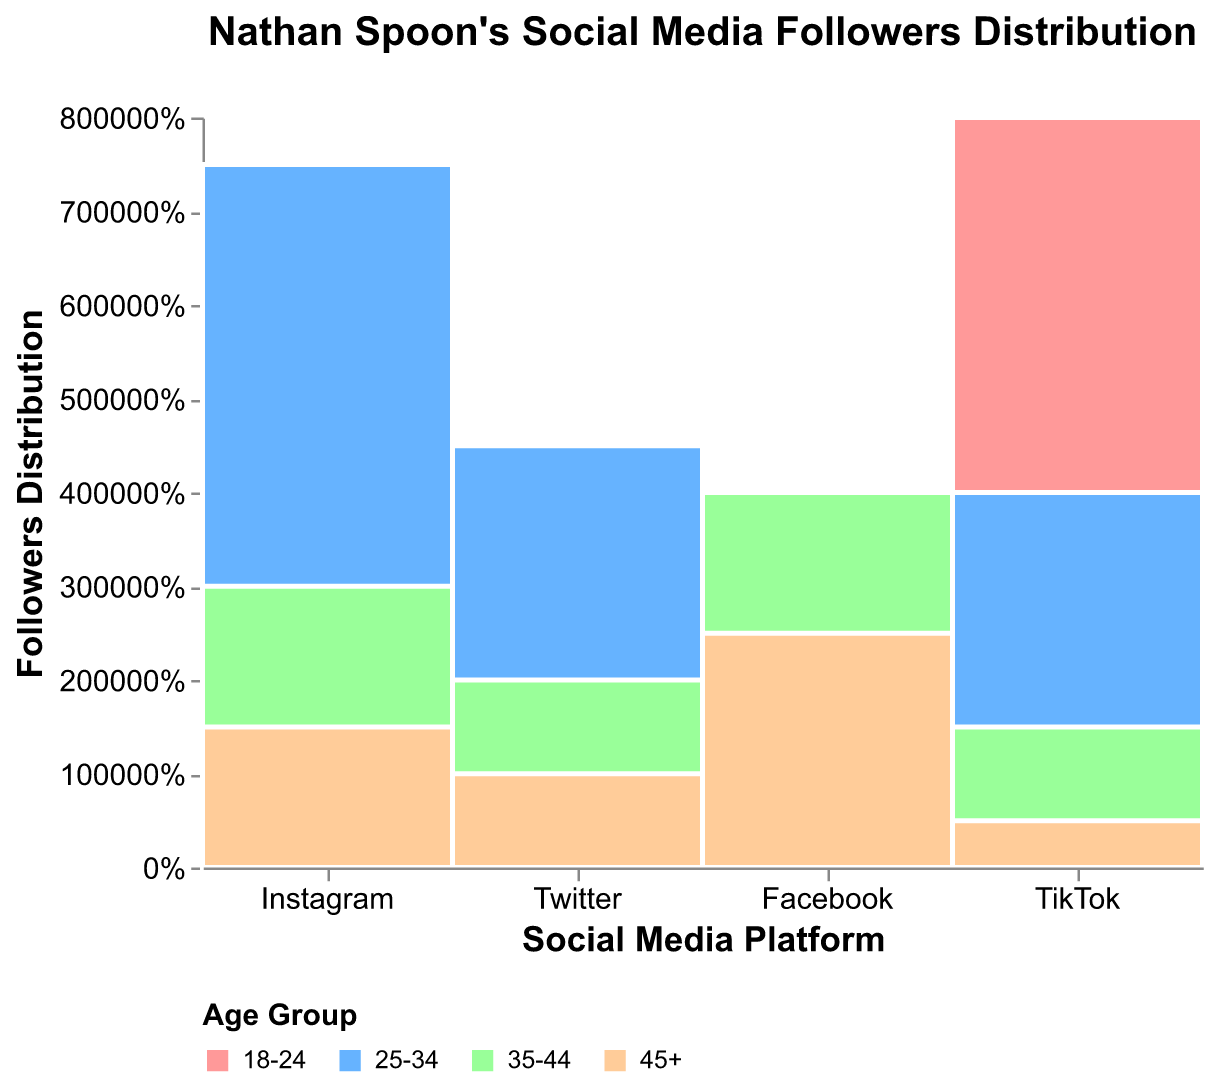What is the title of the figure? The figure title is found at the top and describes what the chart is about. It reads "Nathan Spoon's Social Media Followers Distribution".
Answer: Nathan Spoon's Social Media Followers Distribution Which age group has the highest percentage of followers on TikTok? By observing the color-coded sections of the TikTok bar, the largest section corresponds to the 18-24 age group, indicating they have the highest percentage.
Answer: 18-24 What color represents the age group 25-34? The legend at the bottom of the chart shows the color associated with each age group. The 25-34 age group is represented by the color light blue.
Answer: light blue How many platforms are depicted in the Mosaic Plot? The x-axis shows distinct sections for each social media platform. Counting these sections gives us the total number, which is four: Instagram, Twitter, Facebook, and TikTok.
Answer: 4 Which platform has the least number of followers in the 45+ age group? By comparing the smallest sections of the 45+ age group across all platforms, Twitter has the smallest section in this age group.
Answer: Twitter Between Instagram and Facebook, which platform has a higher number of followers in the age group 35-44? By comparing the sections corresponding to the 35-44 age group for both platforms, Facebook's section is taller than Instagram's.
Answer: Facebook What is the percentage of followers aged 25-34 on Facebook? Observing the height of the 25-34 section (light blue) on the Facebook bar gives the approximate percentage of followers in this age group. The tool-tip can give a more exact value, but visually it’s about 20%.
Answer: 20% How does the proportion of 18-24 age group followers on Instagram compare to those on Twitter? The 18-24 group section for Instagram is larger than that for Twitter, indicating a higher proportion of followers in this age group on Instagram.
Answer: Instagram has a higher proportion Which age group shows the most significant variation in follower distribution across different platforms? By comparing the sections of all age groups across platforms, the 18-24 age group shows the most variation, since it has the largest sections on TikTok and relatively smaller sections on other platforms.
Answer: 18-24 